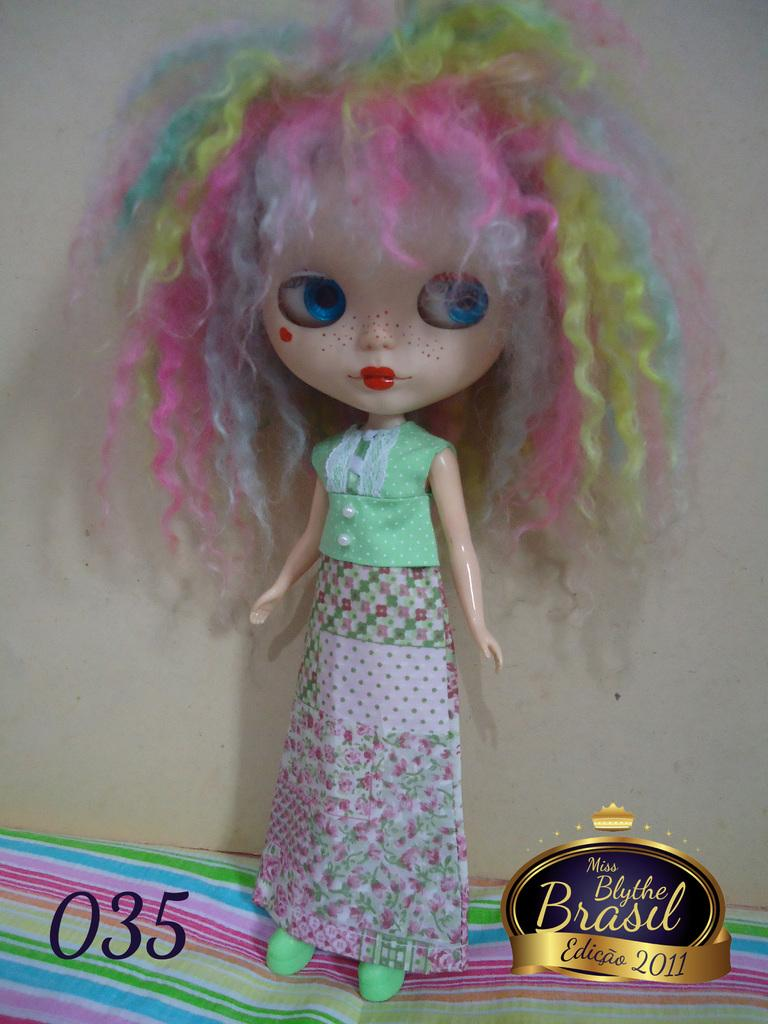What is the main subject of the image? There is a doll in the image. What can be seen in the background of the image? There is a wall in the image. Are there any additional details at the bottom of the image? Yes, there are numbers and a logo at the bottom of the image. Can you tell me how many bikes are parked next to the wall in the image? There are no bikes present in the image; it only features a doll and a wall. What type of cat can be seen playing with the doll in the image? There is no cat present in the image; it only features a doll and a wall. 